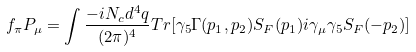Convert formula to latex. <formula><loc_0><loc_0><loc_500><loc_500>f _ { \pi } P _ { \mu } = \int \frac { - i N _ { c } d ^ { 4 } q } { ( 2 \pi ) ^ { 4 } } T r [ \gamma _ { 5 } \Gamma ( p _ { 1 } , p _ { 2 } ) S _ { F } ( p _ { 1 } ) i \gamma _ { \mu } \gamma _ { 5 } S _ { F } ( - p _ { 2 } ) ]</formula> 